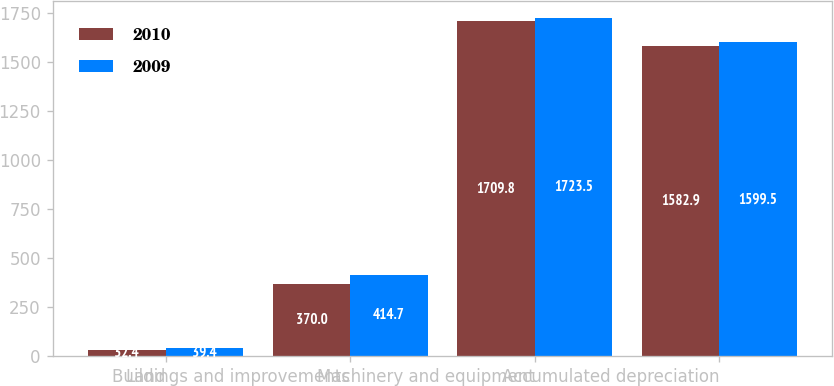<chart> <loc_0><loc_0><loc_500><loc_500><stacked_bar_chart><ecel><fcel>Land<fcel>Buildings and improvements<fcel>Machinery and equipment<fcel>Accumulated depreciation<nl><fcel>2010<fcel>32.4<fcel>370<fcel>1709.8<fcel>1582.9<nl><fcel>2009<fcel>39.4<fcel>414.7<fcel>1723.5<fcel>1599.5<nl></chart> 